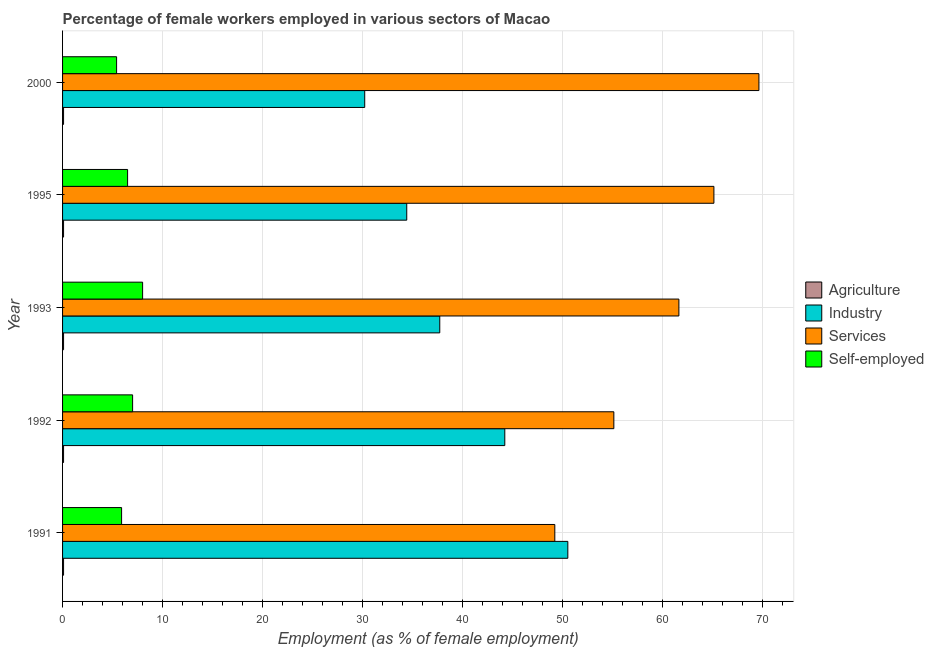How many groups of bars are there?
Your response must be concise. 5. Are the number of bars on each tick of the Y-axis equal?
Keep it short and to the point. Yes. How many bars are there on the 4th tick from the top?
Make the answer very short. 4. How many bars are there on the 3rd tick from the bottom?
Make the answer very short. 4. What is the label of the 4th group of bars from the top?
Offer a very short reply. 1992. In how many cases, is the number of bars for a given year not equal to the number of legend labels?
Ensure brevity in your answer.  0. What is the percentage of self employed female workers in 1991?
Offer a very short reply. 5.9. Across all years, what is the maximum percentage of female workers in services?
Your response must be concise. 69.6. Across all years, what is the minimum percentage of female workers in services?
Give a very brief answer. 49.2. In which year was the percentage of self employed female workers maximum?
Ensure brevity in your answer.  1993. In which year was the percentage of female workers in services minimum?
Offer a very short reply. 1991. What is the total percentage of female workers in services in the graph?
Provide a succinct answer. 300.6. What is the difference between the percentage of female workers in industry in 2000 and the percentage of female workers in agriculture in 1991?
Your answer should be compact. 30.1. What is the average percentage of female workers in agriculture per year?
Make the answer very short. 0.1. In the year 1991, what is the difference between the percentage of female workers in industry and percentage of self employed female workers?
Make the answer very short. 44.6. In how many years, is the percentage of female workers in services greater than 36 %?
Your answer should be very brief. 5. What is the ratio of the percentage of female workers in industry in 1995 to that in 2000?
Your answer should be very brief. 1.14. Is the percentage of female workers in agriculture in 1991 less than that in 1995?
Make the answer very short. No. What is the difference between the highest and the second highest percentage of self employed female workers?
Your response must be concise. 1. What is the difference between the highest and the lowest percentage of female workers in industry?
Your answer should be compact. 20.3. Is the sum of the percentage of female workers in industry in 1992 and 2000 greater than the maximum percentage of self employed female workers across all years?
Give a very brief answer. Yes. What does the 3rd bar from the top in 2000 represents?
Your response must be concise. Industry. What does the 1st bar from the bottom in 2000 represents?
Your answer should be very brief. Agriculture. Is it the case that in every year, the sum of the percentage of female workers in agriculture and percentage of female workers in industry is greater than the percentage of female workers in services?
Make the answer very short. No. Are all the bars in the graph horizontal?
Offer a very short reply. Yes. What is the difference between two consecutive major ticks on the X-axis?
Ensure brevity in your answer.  10. Are the values on the major ticks of X-axis written in scientific E-notation?
Your response must be concise. No. What is the title of the graph?
Provide a succinct answer. Percentage of female workers employed in various sectors of Macao. What is the label or title of the X-axis?
Ensure brevity in your answer.  Employment (as % of female employment). What is the Employment (as % of female employment) in Agriculture in 1991?
Give a very brief answer. 0.1. What is the Employment (as % of female employment) in Industry in 1991?
Your answer should be very brief. 50.5. What is the Employment (as % of female employment) of Services in 1991?
Provide a succinct answer. 49.2. What is the Employment (as % of female employment) of Self-employed in 1991?
Give a very brief answer. 5.9. What is the Employment (as % of female employment) in Agriculture in 1992?
Offer a very short reply. 0.1. What is the Employment (as % of female employment) of Industry in 1992?
Ensure brevity in your answer.  44.2. What is the Employment (as % of female employment) of Services in 1992?
Ensure brevity in your answer.  55.1. What is the Employment (as % of female employment) in Self-employed in 1992?
Offer a terse response. 7. What is the Employment (as % of female employment) in Agriculture in 1993?
Keep it short and to the point. 0.1. What is the Employment (as % of female employment) of Industry in 1993?
Offer a very short reply. 37.7. What is the Employment (as % of female employment) in Services in 1993?
Offer a very short reply. 61.6. What is the Employment (as % of female employment) of Self-employed in 1993?
Offer a terse response. 8. What is the Employment (as % of female employment) of Agriculture in 1995?
Your response must be concise. 0.1. What is the Employment (as % of female employment) of Industry in 1995?
Your answer should be very brief. 34.4. What is the Employment (as % of female employment) in Services in 1995?
Keep it short and to the point. 65.1. What is the Employment (as % of female employment) of Self-employed in 1995?
Give a very brief answer. 6.5. What is the Employment (as % of female employment) of Agriculture in 2000?
Provide a short and direct response. 0.1. What is the Employment (as % of female employment) in Industry in 2000?
Your answer should be very brief. 30.2. What is the Employment (as % of female employment) in Services in 2000?
Give a very brief answer. 69.6. What is the Employment (as % of female employment) of Self-employed in 2000?
Keep it short and to the point. 5.4. Across all years, what is the maximum Employment (as % of female employment) in Agriculture?
Keep it short and to the point. 0.1. Across all years, what is the maximum Employment (as % of female employment) of Industry?
Your answer should be very brief. 50.5. Across all years, what is the maximum Employment (as % of female employment) of Services?
Provide a short and direct response. 69.6. Across all years, what is the minimum Employment (as % of female employment) of Agriculture?
Provide a short and direct response. 0.1. Across all years, what is the minimum Employment (as % of female employment) in Industry?
Offer a very short reply. 30.2. Across all years, what is the minimum Employment (as % of female employment) in Services?
Your answer should be very brief. 49.2. Across all years, what is the minimum Employment (as % of female employment) in Self-employed?
Provide a short and direct response. 5.4. What is the total Employment (as % of female employment) of Industry in the graph?
Keep it short and to the point. 197. What is the total Employment (as % of female employment) in Services in the graph?
Keep it short and to the point. 300.6. What is the total Employment (as % of female employment) in Self-employed in the graph?
Your response must be concise. 32.8. What is the difference between the Employment (as % of female employment) of Agriculture in 1991 and that in 1992?
Offer a very short reply. 0. What is the difference between the Employment (as % of female employment) in Industry in 1991 and that in 1992?
Your response must be concise. 6.3. What is the difference between the Employment (as % of female employment) of Services in 1991 and that in 1993?
Ensure brevity in your answer.  -12.4. What is the difference between the Employment (as % of female employment) in Agriculture in 1991 and that in 1995?
Provide a short and direct response. 0. What is the difference between the Employment (as % of female employment) in Services in 1991 and that in 1995?
Keep it short and to the point. -15.9. What is the difference between the Employment (as % of female employment) of Agriculture in 1991 and that in 2000?
Keep it short and to the point. 0. What is the difference between the Employment (as % of female employment) of Industry in 1991 and that in 2000?
Your answer should be compact. 20.3. What is the difference between the Employment (as % of female employment) in Services in 1991 and that in 2000?
Make the answer very short. -20.4. What is the difference between the Employment (as % of female employment) of Industry in 1992 and that in 1995?
Your response must be concise. 9.8. What is the difference between the Employment (as % of female employment) in Services in 1992 and that in 2000?
Keep it short and to the point. -14.5. What is the difference between the Employment (as % of female employment) in Self-employed in 1992 and that in 2000?
Provide a short and direct response. 1.6. What is the difference between the Employment (as % of female employment) in Agriculture in 1993 and that in 1995?
Your answer should be very brief. 0. What is the difference between the Employment (as % of female employment) of Services in 1993 and that in 1995?
Offer a very short reply. -3.5. What is the difference between the Employment (as % of female employment) of Self-employed in 1993 and that in 1995?
Offer a terse response. 1.5. What is the difference between the Employment (as % of female employment) of Agriculture in 1993 and that in 2000?
Keep it short and to the point. 0. What is the difference between the Employment (as % of female employment) of Services in 1993 and that in 2000?
Offer a terse response. -8. What is the difference between the Employment (as % of female employment) in Self-employed in 1993 and that in 2000?
Offer a terse response. 2.6. What is the difference between the Employment (as % of female employment) in Agriculture in 1995 and that in 2000?
Offer a very short reply. 0. What is the difference between the Employment (as % of female employment) of Self-employed in 1995 and that in 2000?
Offer a terse response. 1.1. What is the difference between the Employment (as % of female employment) in Agriculture in 1991 and the Employment (as % of female employment) in Industry in 1992?
Offer a very short reply. -44.1. What is the difference between the Employment (as % of female employment) of Agriculture in 1991 and the Employment (as % of female employment) of Services in 1992?
Ensure brevity in your answer.  -55. What is the difference between the Employment (as % of female employment) in Agriculture in 1991 and the Employment (as % of female employment) in Self-employed in 1992?
Your response must be concise. -6.9. What is the difference between the Employment (as % of female employment) of Industry in 1991 and the Employment (as % of female employment) of Self-employed in 1992?
Your response must be concise. 43.5. What is the difference between the Employment (as % of female employment) in Services in 1991 and the Employment (as % of female employment) in Self-employed in 1992?
Make the answer very short. 42.2. What is the difference between the Employment (as % of female employment) of Agriculture in 1991 and the Employment (as % of female employment) of Industry in 1993?
Offer a very short reply. -37.6. What is the difference between the Employment (as % of female employment) of Agriculture in 1991 and the Employment (as % of female employment) of Services in 1993?
Your answer should be compact. -61.5. What is the difference between the Employment (as % of female employment) of Agriculture in 1991 and the Employment (as % of female employment) of Self-employed in 1993?
Ensure brevity in your answer.  -7.9. What is the difference between the Employment (as % of female employment) of Industry in 1991 and the Employment (as % of female employment) of Services in 1993?
Make the answer very short. -11.1. What is the difference between the Employment (as % of female employment) in Industry in 1991 and the Employment (as % of female employment) in Self-employed in 1993?
Offer a very short reply. 42.5. What is the difference between the Employment (as % of female employment) of Services in 1991 and the Employment (as % of female employment) of Self-employed in 1993?
Give a very brief answer. 41.2. What is the difference between the Employment (as % of female employment) of Agriculture in 1991 and the Employment (as % of female employment) of Industry in 1995?
Provide a succinct answer. -34.3. What is the difference between the Employment (as % of female employment) of Agriculture in 1991 and the Employment (as % of female employment) of Services in 1995?
Provide a succinct answer. -65. What is the difference between the Employment (as % of female employment) of Agriculture in 1991 and the Employment (as % of female employment) of Self-employed in 1995?
Offer a terse response. -6.4. What is the difference between the Employment (as % of female employment) in Industry in 1991 and the Employment (as % of female employment) in Services in 1995?
Offer a terse response. -14.6. What is the difference between the Employment (as % of female employment) in Industry in 1991 and the Employment (as % of female employment) in Self-employed in 1995?
Your answer should be very brief. 44. What is the difference between the Employment (as % of female employment) of Services in 1991 and the Employment (as % of female employment) of Self-employed in 1995?
Your response must be concise. 42.7. What is the difference between the Employment (as % of female employment) of Agriculture in 1991 and the Employment (as % of female employment) of Industry in 2000?
Offer a terse response. -30.1. What is the difference between the Employment (as % of female employment) in Agriculture in 1991 and the Employment (as % of female employment) in Services in 2000?
Your answer should be very brief. -69.5. What is the difference between the Employment (as % of female employment) in Industry in 1991 and the Employment (as % of female employment) in Services in 2000?
Your response must be concise. -19.1. What is the difference between the Employment (as % of female employment) of Industry in 1991 and the Employment (as % of female employment) of Self-employed in 2000?
Your response must be concise. 45.1. What is the difference between the Employment (as % of female employment) in Services in 1991 and the Employment (as % of female employment) in Self-employed in 2000?
Offer a very short reply. 43.8. What is the difference between the Employment (as % of female employment) in Agriculture in 1992 and the Employment (as % of female employment) in Industry in 1993?
Ensure brevity in your answer.  -37.6. What is the difference between the Employment (as % of female employment) of Agriculture in 1992 and the Employment (as % of female employment) of Services in 1993?
Offer a terse response. -61.5. What is the difference between the Employment (as % of female employment) in Industry in 1992 and the Employment (as % of female employment) in Services in 1993?
Make the answer very short. -17.4. What is the difference between the Employment (as % of female employment) of Industry in 1992 and the Employment (as % of female employment) of Self-employed in 1993?
Offer a terse response. 36.2. What is the difference between the Employment (as % of female employment) of Services in 1992 and the Employment (as % of female employment) of Self-employed in 1993?
Provide a succinct answer. 47.1. What is the difference between the Employment (as % of female employment) of Agriculture in 1992 and the Employment (as % of female employment) of Industry in 1995?
Your answer should be compact. -34.3. What is the difference between the Employment (as % of female employment) of Agriculture in 1992 and the Employment (as % of female employment) of Services in 1995?
Your answer should be compact. -65. What is the difference between the Employment (as % of female employment) of Agriculture in 1992 and the Employment (as % of female employment) of Self-employed in 1995?
Provide a short and direct response. -6.4. What is the difference between the Employment (as % of female employment) of Industry in 1992 and the Employment (as % of female employment) of Services in 1995?
Ensure brevity in your answer.  -20.9. What is the difference between the Employment (as % of female employment) of Industry in 1992 and the Employment (as % of female employment) of Self-employed in 1995?
Your response must be concise. 37.7. What is the difference between the Employment (as % of female employment) of Services in 1992 and the Employment (as % of female employment) of Self-employed in 1995?
Offer a very short reply. 48.6. What is the difference between the Employment (as % of female employment) of Agriculture in 1992 and the Employment (as % of female employment) of Industry in 2000?
Provide a succinct answer. -30.1. What is the difference between the Employment (as % of female employment) in Agriculture in 1992 and the Employment (as % of female employment) in Services in 2000?
Give a very brief answer. -69.5. What is the difference between the Employment (as % of female employment) of Industry in 1992 and the Employment (as % of female employment) of Services in 2000?
Your answer should be compact. -25.4. What is the difference between the Employment (as % of female employment) in Industry in 1992 and the Employment (as % of female employment) in Self-employed in 2000?
Offer a terse response. 38.8. What is the difference between the Employment (as % of female employment) of Services in 1992 and the Employment (as % of female employment) of Self-employed in 2000?
Offer a terse response. 49.7. What is the difference between the Employment (as % of female employment) in Agriculture in 1993 and the Employment (as % of female employment) in Industry in 1995?
Provide a short and direct response. -34.3. What is the difference between the Employment (as % of female employment) in Agriculture in 1993 and the Employment (as % of female employment) in Services in 1995?
Make the answer very short. -65. What is the difference between the Employment (as % of female employment) of Agriculture in 1993 and the Employment (as % of female employment) of Self-employed in 1995?
Your response must be concise. -6.4. What is the difference between the Employment (as % of female employment) of Industry in 1993 and the Employment (as % of female employment) of Services in 1995?
Give a very brief answer. -27.4. What is the difference between the Employment (as % of female employment) in Industry in 1993 and the Employment (as % of female employment) in Self-employed in 1995?
Ensure brevity in your answer.  31.2. What is the difference between the Employment (as % of female employment) in Services in 1993 and the Employment (as % of female employment) in Self-employed in 1995?
Make the answer very short. 55.1. What is the difference between the Employment (as % of female employment) of Agriculture in 1993 and the Employment (as % of female employment) of Industry in 2000?
Your answer should be very brief. -30.1. What is the difference between the Employment (as % of female employment) in Agriculture in 1993 and the Employment (as % of female employment) in Services in 2000?
Offer a very short reply. -69.5. What is the difference between the Employment (as % of female employment) in Industry in 1993 and the Employment (as % of female employment) in Services in 2000?
Make the answer very short. -31.9. What is the difference between the Employment (as % of female employment) of Industry in 1993 and the Employment (as % of female employment) of Self-employed in 2000?
Provide a succinct answer. 32.3. What is the difference between the Employment (as % of female employment) of Services in 1993 and the Employment (as % of female employment) of Self-employed in 2000?
Keep it short and to the point. 56.2. What is the difference between the Employment (as % of female employment) of Agriculture in 1995 and the Employment (as % of female employment) of Industry in 2000?
Provide a succinct answer. -30.1. What is the difference between the Employment (as % of female employment) in Agriculture in 1995 and the Employment (as % of female employment) in Services in 2000?
Your response must be concise. -69.5. What is the difference between the Employment (as % of female employment) of Industry in 1995 and the Employment (as % of female employment) of Services in 2000?
Your answer should be very brief. -35.2. What is the difference between the Employment (as % of female employment) in Industry in 1995 and the Employment (as % of female employment) in Self-employed in 2000?
Offer a very short reply. 29. What is the difference between the Employment (as % of female employment) in Services in 1995 and the Employment (as % of female employment) in Self-employed in 2000?
Provide a succinct answer. 59.7. What is the average Employment (as % of female employment) in Industry per year?
Your answer should be compact. 39.4. What is the average Employment (as % of female employment) in Services per year?
Your answer should be very brief. 60.12. What is the average Employment (as % of female employment) of Self-employed per year?
Keep it short and to the point. 6.56. In the year 1991, what is the difference between the Employment (as % of female employment) in Agriculture and Employment (as % of female employment) in Industry?
Keep it short and to the point. -50.4. In the year 1991, what is the difference between the Employment (as % of female employment) in Agriculture and Employment (as % of female employment) in Services?
Offer a very short reply. -49.1. In the year 1991, what is the difference between the Employment (as % of female employment) of Industry and Employment (as % of female employment) of Services?
Your response must be concise. 1.3. In the year 1991, what is the difference between the Employment (as % of female employment) in Industry and Employment (as % of female employment) in Self-employed?
Give a very brief answer. 44.6. In the year 1991, what is the difference between the Employment (as % of female employment) in Services and Employment (as % of female employment) in Self-employed?
Keep it short and to the point. 43.3. In the year 1992, what is the difference between the Employment (as % of female employment) of Agriculture and Employment (as % of female employment) of Industry?
Provide a short and direct response. -44.1. In the year 1992, what is the difference between the Employment (as % of female employment) of Agriculture and Employment (as % of female employment) of Services?
Keep it short and to the point. -55. In the year 1992, what is the difference between the Employment (as % of female employment) in Agriculture and Employment (as % of female employment) in Self-employed?
Offer a terse response. -6.9. In the year 1992, what is the difference between the Employment (as % of female employment) of Industry and Employment (as % of female employment) of Services?
Make the answer very short. -10.9. In the year 1992, what is the difference between the Employment (as % of female employment) in Industry and Employment (as % of female employment) in Self-employed?
Your answer should be compact. 37.2. In the year 1992, what is the difference between the Employment (as % of female employment) in Services and Employment (as % of female employment) in Self-employed?
Provide a short and direct response. 48.1. In the year 1993, what is the difference between the Employment (as % of female employment) of Agriculture and Employment (as % of female employment) of Industry?
Offer a terse response. -37.6. In the year 1993, what is the difference between the Employment (as % of female employment) in Agriculture and Employment (as % of female employment) in Services?
Your answer should be very brief. -61.5. In the year 1993, what is the difference between the Employment (as % of female employment) in Industry and Employment (as % of female employment) in Services?
Make the answer very short. -23.9. In the year 1993, what is the difference between the Employment (as % of female employment) in Industry and Employment (as % of female employment) in Self-employed?
Your answer should be very brief. 29.7. In the year 1993, what is the difference between the Employment (as % of female employment) of Services and Employment (as % of female employment) of Self-employed?
Ensure brevity in your answer.  53.6. In the year 1995, what is the difference between the Employment (as % of female employment) in Agriculture and Employment (as % of female employment) in Industry?
Provide a short and direct response. -34.3. In the year 1995, what is the difference between the Employment (as % of female employment) in Agriculture and Employment (as % of female employment) in Services?
Your answer should be compact. -65. In the year 1995, what is the difference between the Employment (as % of female employment) in Agriculture and Employment (as % of female employment) in Self-employed?
Ensure brevity in your answer.  -6.4. In the year 1995, what is the difference between the Employment (as % of female employment) of Industry and Employment (as % of female employment) of Services?
Offer a very short reply. -30.7. In the year 1995, what is the difference between the Employment (as % of female employment) in Industry and Employment (as % of female employment) in Self-employed?
Your response must be concise. 27.9. In the year 1995, what is the difference between the Employment (as % of female employment) in Services and Employment (as % of female employment) in Self-employed?
Ensure brevity in your answer.  58.6. In the year 2000, what is the difference between the Employment (as % of female employment) of Agriculture and Employment (as % of female employment) of Industry?
Give a very brief answer. -30.1. In the year 2000, what is the difference between the Employment (as % of female employment) of Agriculture and Employment (as % of female employment) of Services?
Offer a very short reply. -69.5. In the year 2000, what is the difference between the Employment (as % of female employment) in Industry and Employment (as % of female employment) in Services?
Provide a short and direct response. -39.4. In the year 2000, what is the difference between the Employment (as % of female employment) in Industry and Employment (as % of female employment) in Self-employed?
Your answer should be compact. 24.8. In the year 2000, what is the difference between the Employment (as % of female employment) in Services and Employment (as % of female employment) in Self-employed?
Keep it short and to the point. 64.2. What is the ratio of the Employment (as % of female employment) in Industry in 1991 to that in 1992?
Give a very brief answer. 1.14. What is the ratio of the Employment (as % of female employment) in Services in 1991 to that in 1992?
Ensure brevity in your answer.  0.89. What is the ratio of the Employment (as % of female employment) of Self-employed in 1991 to that in 1992?
Provide a succinct answer. 0.84. What is the ratio of the Employment (as % of female employment) in Agriculture in 1991 to that in 1993?
Offer a very short reply. 1. What is the ratio of the Employment (as % of female employment) in Industry in 1991 to that in 1993?
Offer a terse response. 1.34. What is the ratio of the Employment (as % of female employment) in Services in 1991 to that in 1993?
Keep it short and to the point. 0.8. What is the ratio of the Employment (as % of female employment) in Self-employed in 1991 to that in 1993?
Your answer should be very brief. 0.74. What is the ratio of the Employment (as % of female employment) of Industry in 1991 to that in 1995?
Give a very brief answer. 1.47. What is the ratio of the Employment (as % of female employment) in Services in 1991 to that in 1995?
Ensure brevity in your answer.  0.76. What is the ratio of the Employment (as % of female employment) in Self-employed in 1991 to that in 1995?
Give a very brief answer. 0.91. What is the ratio of the Employment (as % of female employment) of Agriculture in 1991 to that in 2000?
Keep it short and to the point. 1. What is the ratio of the Employment (as % of female employment) of Industry in 1991 to that in 2000?
Provide a short and direct response. 1.67. What is the ratio of the Employment (as % of female employment) in Services in 1991 to that in 2000?
Give a very brief answer. 0.71. What is the ratio of the Employment (as % of female employment) in Self-employed in 1991 to that in 2000?
Your response must be concise. 1.09. What is the ratio of the Employment (as % of female employment) of Agriculture in 1992 to that in 1993?
Provide a short and direct response. 1. What is the ratio of the Employment (as % of female employment) of Industry in 1992 to that in 1993?
Keep it short and to the point. 1.17. What is the ratio of the Employment (as % of female employment) in Services in 1992 to that in 1993?
Your response must be concise. 0.89. What is the ratio of the Employment (as % of female employment) of Agriculture in 1992 to that in 1995?
Provide a short and direct response. 1. What is the ratio of the Employment (as % of female employment) of Industry in 1992 to that in 1995?
Give a very brief answer. 1.28. What is the ratio of the Employment (as % of female employment) of Services in 1992 to that in 1995?
Your answer should be very brief. 0.85. What is the ratio of the Employment (as % of female employment) of Agriculture in 1992 to that in 2000?
Your answer should be very brief. 1. What is the ratio of the Employment (as % of female employment) of Industry in 1992 to that in 2000?
Provide a succinct answer. 1.46. What is the ratio of the Employment (as % of female employment) of Services in 1992 to that in 2000?
Your response must be concise. 0.79. What is the ratio of the Employment (as % of female employment) in Self-employed in 1992 to that in 2000?
Offer a terse response. 1.3. What is the ratio of the Employment (as % of female employment) of Agriculture in 1993 to that in 1995?
Make the answer very short. 1. What is the ratio of the Employment (as % of female employment) of Industry in 1993 to that in 1995?
Make the answer very short. 1.1. What is the ratio of the Employment (as % of female employment) in Services in 1993 to that in 1995?
Give a very brief answer. 0.95. What is the ratio of the Employment (as % of female employment) of Self-employed in 1993 to that in 1995?
Keep it short and to the point. 1.23. What is the ratio of the Employment (as % of female employment) of Agriculture in 1993 to that in 2000?
Provide a short and direct response. 1. What is the ratio of the Employment (as % of female employment) of Industry in 1993 to that in 2000?
Ensure brevity in your answer.  1.25. What is the ratio of the Employment (as % of female employment) in Services in 1993 to that in 2000?
Keep it short and to the point. 0.89. What is the ratio of the Employment (as % of female employment) in Self-employed in 1993 to that in 2000?
Provide a short and direct response. 1.48. What is the ratio of the Employment (as % of female employment) of Agriculture in 1995 to that in 2000?
Offer a very short reply. 1. What is the ratio of the Employment (as % of female employment) in Industry in 1995 to that in 2000?
Your response must be concise. 1.14. What is the ratio of the Employment (as % of female employment) of Services in 1995 to that in 2000?
Give a very brief answer. 0.94. What is the ratio of the Employment (as % of female employment) in Self-employed in 1995 to that in 2000?
Make the answer very short. 1.2. What is the difference between the highest and the second highest Employment (as % of female employment) of Services?
Offer a terse response. 4.5. What is the difference between the highest and the lowest Employment (as % of female employment) of Industry?
Give a very brief answer. 20.3. What is the difference between the highest and the lowest Employment (as % of female employment) of Services?
Offer a very short reply. 20.4. 